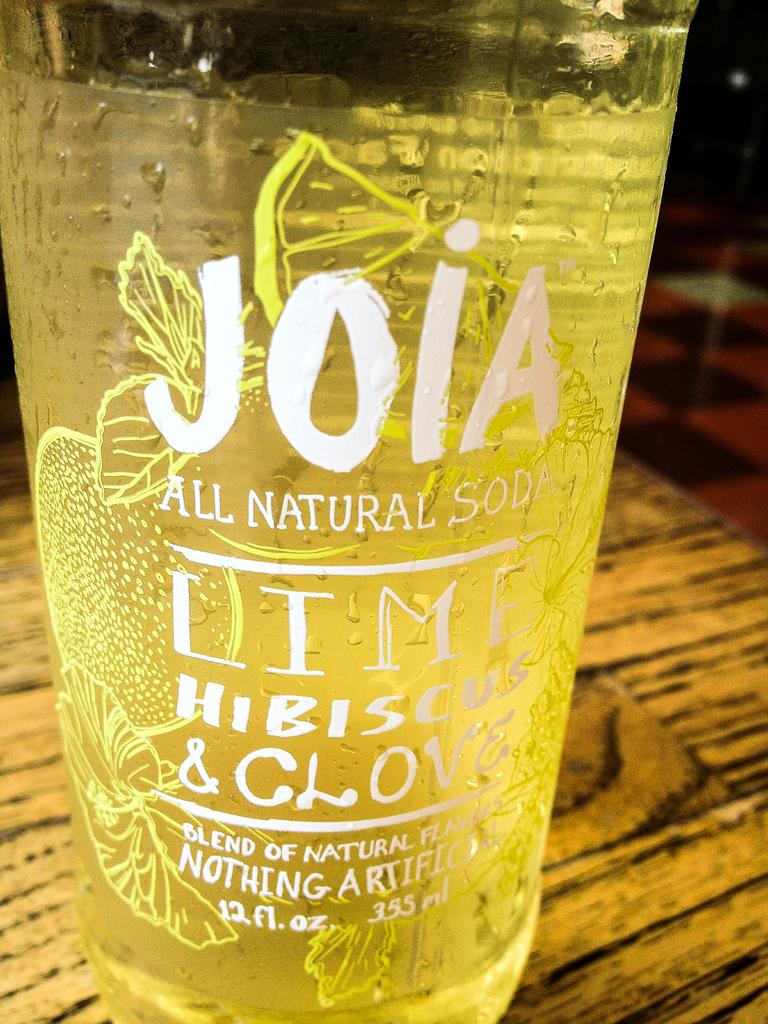Provide a one-sentence caption for the provided image. A glass with the writing Joia all natural soda lime hibiscus and clove on it. 